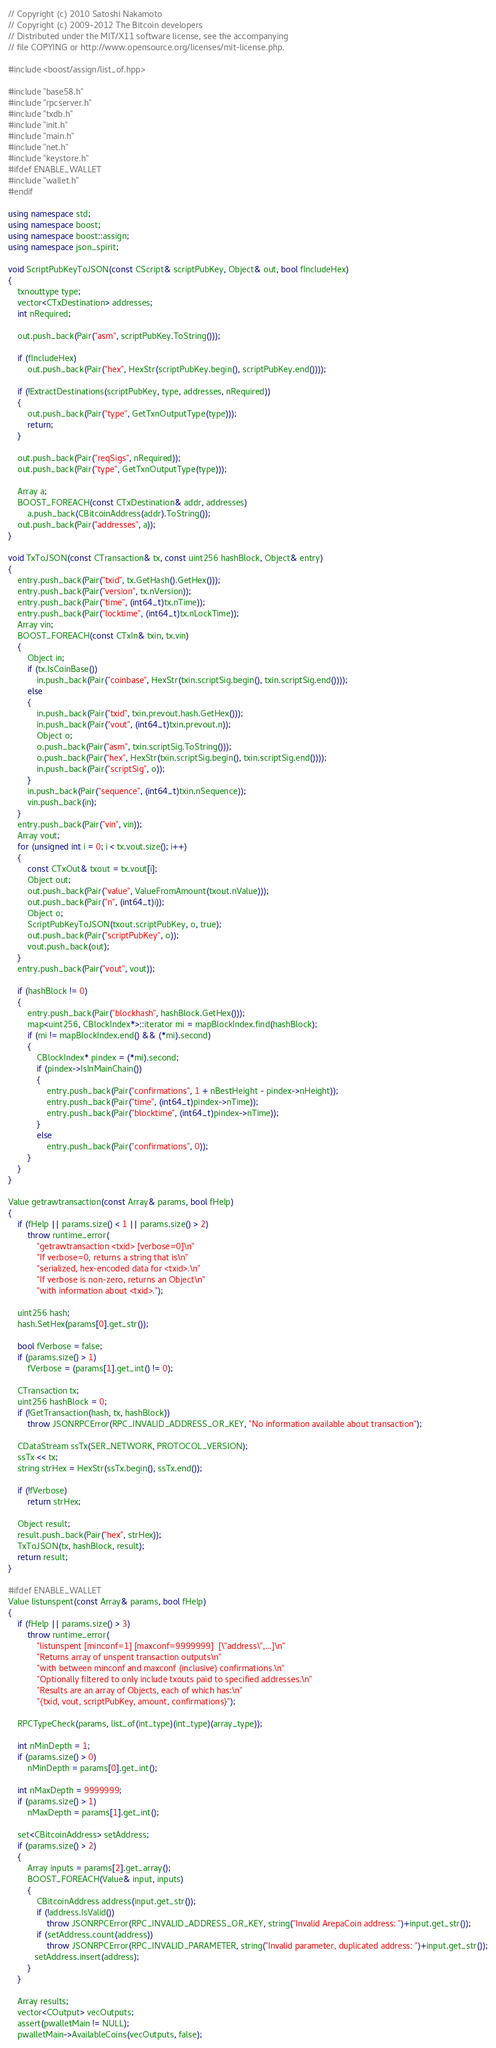<code> <loc_0><loc_0><loc_500><loc_500><_C++_>// Copyright (c) 2010 Satoshi Nakamoto
// Copyright (c) 2009-2012 The Bitcoin developers
// Distributed under the MIT/X11 software license, see the accompanying
// file COPYING or http://www.opensource.org/licenses/mit-license.php.

#include <boost/assign/list_of.hpp>

#include "base58.h"
#include "rpcserver.h"
#include "txdb.h"
#include "init.h"
#include "main.h"
#include "net.h"
#include "keystore.h"
#ifdef ENABLE_WALLET
#include "wallet.h"
#endif

using namespace std;
using namespace boost;
using namespace boost::assign;
using namespace json_spirit;

void ScriptPubKeyToJSON(const CScript& scriptPubKey, Object& out, bool fIncludeHex)
{
    txnouttype type;
    vector<CTxDestination> addresses;
    int nRequired;

    out.push_back(Pair("asm", scriptPubKey.ToString()));

    if (fIncludeHex)
        out.push_back(Pair("hex", HexStr(scriptPubKey.begin(), scriptPubKey.end())));

    if (!ExtractDestinations(scriptPubKey, type, addresses, nRequired))
    {
        out.push_back(Pair("type", GetTxnOutputType(type)));
        return;
    }

    out.push_back(Pair("reqSigs", nRequired));
    out.push_back(Pair("type", GetTxnOutputType(type)));

    Array a;
    BOOST_FOREACH(const CTxDestination& addr, addresses)
        a.push_back(CBitcoinAddress(addr).ToString());
    out.push_back(Pair("addresses", a));
}

void TxToJSON(const CTransaction& tx, const uint256 hashBlock, Object& entry)
{
    entry.push_back(Pair("txid", tx.GetHash().GetHex()));
    entry.push_back(Pair("version", tx.nVersion));
    entry.push_back(Pair("time", (int64_t)tx.nTime));
    entry.push_back(Pair("locktime", (int64_t)tx.nLockTime));
    Array vin;
    BOOST_FOREACH(const CTxIn& txin, tx.vin)
    {
        Object in;
        if (tx.IsCoinBase())
            in.push_back(Pair("coinbase", HexStr(txin.scriptSig.begin(), txin.scriptSig.end())));
        else
        {
            in.push_back(Pair("txid", txin.prevout.hash.GetHex()));
            in.push_back(Pair("vout", (int64_t)txin.prevout.n));
            Object o;
            o.push_back(Pair("asm", txin.scriptSig.ToString()));
            o.push_back(Pair("hex", HexStr(txin.scriptSig.begin(), txin.scriptSig.end())));
            in.push_back(Pair("scriptSig", o));
        }
        in.push_back(Pair("sequence", (int64_t)txin.nSequence));
        vin.push_back(in);
    }
    entry.push_back(Pair("vin", vin));
    Array vout;
    for (unsigned int i = 0; i < tx.vout.size(); i++)
    {
        const CTxOut& txout = tx.vout[i];
        Object out;
        out.push_back(Pair("value", ValueFromAmount(txout.nValue)));
        out.push_back(Pair("n", (int64_t)i));
        Object o;
        ScriptPubKeyToJSON(txout.scriptPubKey, o, true);
        out.push_back(Pair("scriptPubKey", o));
        vout.push_back(out);
    }
    entry.push_back(Pair("vout", vout));

    if (hashBlock != 0)
    {
        entry.push_back(Pair("blockhash", hashBlock.GetHex()));
        map<uint256, CBlockIndex*>::iterator mi = mapBlockIndex.find(hashBlock);
        if (mi != mapBlockIndex.end() && (*mi).second)
        {
            CBlockIndex* pindex = (*mi).second;
            if (pindex->IsInMainChain())
            {
                entry.push_back(Pair("confirmations", 1 + nBestHeight - pindex->nHeight));
                entry.push_back(Pair("time", (int64_t)pindex->nTime));
                entry.push_back(Pair("blocktime", (int64_t)pindex->nTime));
            }
            else
                entry.push_back(Pair("confirmations", 0));
        }
    }
}

Value getrawtransaction(const Array& params, bool fHelp)
{
    if (fHelp || params.size() < 1 || params.size() > 2)
        throw runtime_error(
            "getrawtransaction <txid> [verbose=0]\n"
            "If verbose=0, returns a string that is\n"
            "serialized, hex-encoded data for <txid>.\n"
            "If verbose is non-zero, returns an Object\n"
            "with information about <txid>.");

    uint256 hash;
    hash.SetHex(params[0].get_str());

    bool fVerbose = false;
    if (params.size() > 1)
        fVerbose = (params[1].get_int() != 0);

    CTransaction tx;
    uint256 hashBlock = 0;
    if (!GetTransaction(hash, tx, hashBlock))
        throw JSONRPCError(RPC_INVALID_ADDRESS_OR_KEY, "No information available about transaction");

    CDataStream ssTx(SER_NETWORK, PROTOCOL_VERSION);
    ssTx << tx;
    string strHex = HexStr(ssTx.begin(), ssTx.end());

    if (!fVerbose)
        return strHex;

    Object result;
    result.push_back(Pair("hex", strHex));
    TxToJSON(tx, hashBlock, result);
    return result;
}

#ifdef ENABLE_WALLET
Value listunspent(const Array& params, bool fHelp)
{
    if (fHelp || params.size() > 3)
        throw runtime_error(
            "listunspent [minconf=1] [maxconf=9999999]  [\"address\",...]\n"
            "Returns array of unspent transaction outputs\n"
            "with between minconf and maxconf (inclusive) confirmations.\n"
            "Optionally filtered to only include txouts paid to specified addresses.\n"
            "Results are an array of Objects, each of which has:\n"
            "{txid, vout, scriptPubKey, amount, confirmations}");

    RPCTypeCheck(params, list_of(int_type)(int_type)(array_type));

    int nMinDepth = 1;
    if (params.size() > 0)
        nMinDepth = params[0].get_int();

    int nMaxDepth = 9999999;
    if (params.size() > 1)
        nMaxDepth = params[1].get_int();

    set<CBitcoinAddress> setAddress;
    if (params.size() > 2)
    {
        Array inputs = params[2].get_array();
        BOOST_FOREACH(Value& input, inputs)
        {
            CBitcoinAddress address(input.get_str());
            if (!address.IsValid())
                throw JSONRPCError(RPC_INVALID_ADDRESS_OR_KEY, string("Invalid ArepaCoin address: ")+input.get_str());
            if (setAddress.count(address))
                throw JSONRPCError(RPC_INVALID_PARAMETER, string("Invalid parameter, duplicated address: ")+input.get_str());
           setAddress.insert(address);
        }
    }

    Array results;
    vector<COutput> vecOutputs;
    assert(pwalletMain != NULL);
    pwalletMain->AvailableCoins(vecOutputs, false);</code> 